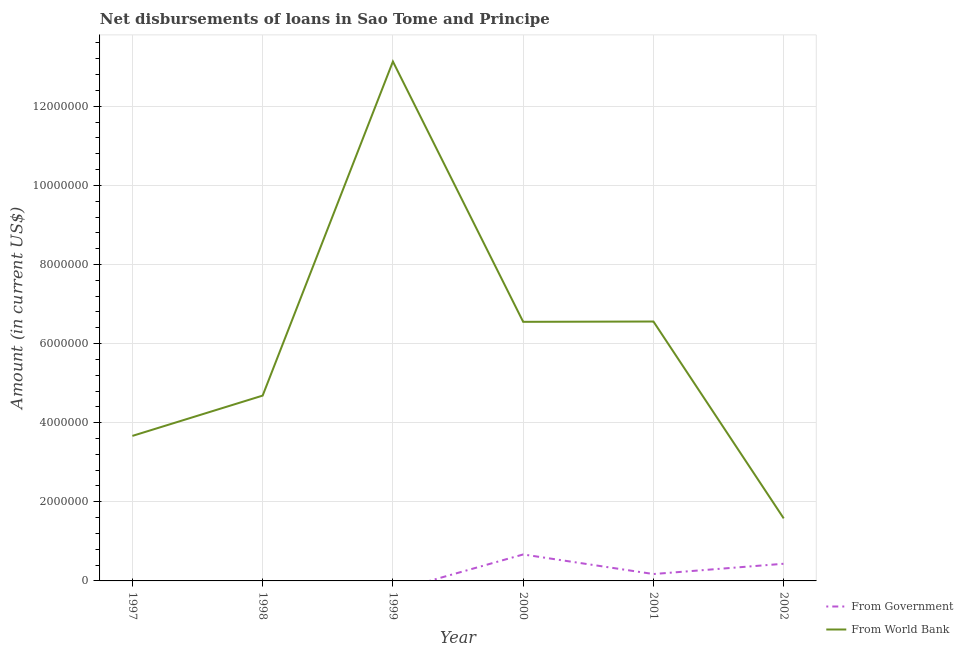Does the line corresponding to net disbursements of loan from world bank intersect with the line corresponding to net disbursements of loan from government?
Offer a terse response. No. Is the number of lines equal to the number of legend labels?
Provide a succinct answer. No. Across all years, what is the maximum net disbursements of loan from government?
Your answer should be very brief. 6.69e+05. Across all years, what is the minimum net disbursements of loan from government?
Provide a succinct answer. 0. What is the total net disbursements of loan from government in the graph?
Your response must be concise. 1.28e+06. What is the difference between the net disbursements of loan from world bank in 1998 and that in 1999?
Offer a terse response. -8.45e+06. What is the difference between the net disbursements of loan from government in 1998 and the net disbursements of loan from world bank in 1999?
Provide a short and direct response. -1.31e+07. What is the average net disbursements of loan from government per year?
Offer a very short reply. 2.13e+05. In the year 2001, what is the difference between the net disbursements of loan from government and net disbursements of loan from world bank?
Your answer should be compact. -6.38e+06. In how many years, is the net disbursements of loan from world bank greater than 11600000 US$?
Offer a very short reply. 1. What is the ratio of the net disbursements of loan from world bank in 2000 to that in 2001?
Your answer should be very brief. 1. Is the net disbursements of loan from government in 2001 less than that in 2002?
Offer a very short reply. Yes. What is the difference between the highest and the second highest net disbursements of loan from world bank?
Ensure brevity in your answer.  6.57e+06. What is the difference between the highest and the lowest net disbursements of loan from government?
Keep it short and to the point. 6.69e+05. Does the net disbursements of loan from government monotonically increase over the years?
Provide a succinct answer. No. Is the net disbursements of loan from government strictly greater than the net disbursements of loan from world bank over the years?
Your response must be concise. No. Is the net disbursements of loan from world bank strictly less than the net disbursements of loan from government over the years?
Your answer should be very brief. No. How many lines are there?
Give a very brief answer. 2. How many years are there in the graph?
Your response must be concise. 6. What is the difference between two consecutive major ticks on the Y-axis?
Offer a very short reply. 2.00e+06. Are the values on the major ticks of Y-axis written in scientific E-notation?
Give a very brief answer. No. Does the graph contain grids?
Your response must be concise. Yes. How many legend labels are there?
Your answer should be compact. 2. How are the legend labels stacked?
Offer a terse response. Vertical. What is the title of the graph?
Provide a short and direct response. Net disbursements of loans in Sao Tome and Principe. Does "External balance on goods" appear as one of the legend labels in the graph?
Offer a terse response. No. What is the label or title of the Y-axis?
Keep it short and to the point. Amount (in current US$). What is the Amount (in current US$) of From World Bank in 1997?
Give a very brief answer. 3.67e+06. What is the Amount (in current US$) of From World Bank in 1998?
Your answer should be very brief. 4.68e+06. What is the Amount (in current US$) in From World Bank in 1999?
Provide a succinct answer. 1.31e+07. What is the Amount (in current US$) in From Government in 2000?
Keep it short and to the point. 6.69e+05. What is the Amount (in current US$) in From World Bank in 2000?
Offer a very short reply. 6.55e+06. What is the Amount (in current US$) in From Government in 2001?
Offer a terse response. 1.74e+05. What is the Amount (in current US$) of From World Bank in 2001?
Give a very brief answer. 6.56e+06. What is the Amount (in current US$) of From Government in 2002?
Your response must be concise. 4.34e+05. What is the Amount (in current US$) in From World Bank in 2002?
Your answer should be very brief. 1.58e+06. Across all years, what is the maximum Amount (in current US$) of From Government?
Give a very brief answer. 6.69e+05. Across all years, what is the maximum Amount (in current US$) of From World Bank?
Your response must be concise. 1.31e+07. Across all years, what is the minimum Amount (in current US$) in From Government?
Give a very brief answer. 0. Across all years, what is the minimum Amount (in current US$) of From World Bank?
Provide a short and direct response. 1.58e+06. What is the total Amount (in current US$) of From Government in the graph?
Your answer should be very brief. 1.28e+06. What is the total Amount (in current US$) of From World Bank in the graph?
Provide a short and direct response. 3.62e+07. What is the difference between the Amount (in current US$) in From World Bank in 1997 and that in 1998?
Provide a short and direct response. -1.02e+06. What is the difference between the Amount (in current US$) of From World Bank in 1997 and that in 1999?
Give a very brief answer. -9.46e+06. What is the difference between the Amount (in current US$) in From World Bank in 1997 and that in 2000?
Make the answer very short. -2.88e+06. What is the difference between the Amount (in current US$) of From World Bank in 1997 and that in 2001?
Ensure brevity in your answer.  -2.89e+06. What is the difference between the Amount (in current US$) of From World Bank in 1997 and that in 2002?
Provide a succinct answer. 2.08e+06. What is the difference between the Amount (in current US$) of From World Bank in 1998 and that in 1999?
Provide a succinct answer. -8.45e+06. What is the difference between the Amount (in current US$) of From World Bank in 1998 and that in 2000?
Make the answer very short. -1.86e+06. What is the difference between the Amount (in current US$) of From World Bank in 1998 and that in 2001?
Provide a short and direct response. -1.87e+06. What is the difference between the Amount (in current US$) in From World Bank in 1998 and that in 2002?
Your response must be concise. 3.10e+06. What is the difference between the Amount (in current US$) in From World Bank in 1999 and that in 2000?
Your answer should be compact. 6.58e+06. What is the difference between the Amount (in current US$) of From World Bank in 1999 and that in 2001?
Your answer should be very brief. 6.57e+06. What is the difference between the Amount (in current US$) of From World Bank in 1999 and that in 2002?
Ensure brevity in your answer.  1.16e+07. What is the difference between the Amount (in current US$) in From Government in 2000 and that in 2001?
Ensure brevity in your answer.  4.95e+05. What is the difference between the Amount (in current US$) of From World Bank in 2000 and that in 2001?
Your answer should be very brief. -8000. What is the difference between the Amount (in current US$) in From Government in 2000 and that in 2002?
Your answer should be very brief. 2.35e+05. What is the difference between the Amount (in current US$) in From World Bank in 2000 and that in 2002?
Keep it short and to the point. 4.97e+06. What is the difference between the Amount (in current US$) of From World Bank in 2001 and that in 2002?
Your response must be concise. 4.98e+06. What is the difference between the Amount (in current US$) in From Government in 2000 and the Amount (in current US$) in From World Bank in 2001?
Offer a terse response. -5.89e+06. What is the difference between the Amount (in current US$) of From Government in 2000 and the Amount (in current US$) of From World Bank in 2002?
Provide a short and direct response. -9.12e+05. What is the difference between the Amount (in current US$) of From Government in 2001 and the Amount (in current US$) of From World Bank in 2002?
Your response must be concise. -1.41e+06. What is the average Amount (in current US$) of From Government per year?
Your answer should be very brief. 2.13e+05. What is the average Amount (in current US$) of From World Bank per year?
Offer a very short reply. 6.03e+06. In the year 2000, what is the difference between the Amount (in current US$) in From Government and Amount (in current US$) in From World Bank?
Provide a succinct answer. -5.88e+06. In the year 2001, what is the difference between the Amount (in current US$) of From Government and Amount (in current US$) of From World Bank?
Give a very brief answer. -6.38e+06. In the year 2002, what is the difference between the Amount (in current US$) in From Government and Amount (in current US$) in From World Bank?
Provide a succinct answer. -1.15e+06. What is the ratio of the Amount (in current US$) in From World Bank in 1997 to that in 1998?
Provide a short and direct response. 0.78. What is the ratio of the Amount (in current US$) of From World Bank in 1997 to that in 1999?
Ensure brevity in your answer.  0.28. What is the ratio of the Amount (in current US$) in From World Bank in 1997 to that in 2000?
Ensure brevity in your answer.  0.56. What is the ratio of the Amount (in current US$) in From World Bank in 1997 to that in 2001?
Offer a terse response. 0.56. What is the ratio of the Amount (in current US$) in From World Bank in 1997 to that in 2002?
Keep it short and to the point. 2.32. What is the ratio of the Amount (in current US$) in From World Bank in 1998 to that in 1999?
Keep it short and to the point. 0.36. What is the ratio of the Amount (in current US$) in From World Bank in 1998 to that in 2000?
Provide a short and direct response. 0.72. What is the ratio of the Amount (in current US$) of From World Bank in 1998 to that in 2001?
Provide a succinct answer. 0.71. What is the ratio of the Amount (in current US$) of From World Bank in 1998 to that in 2002?
Make the answer very short. 2.96. What is the ratio of the Amount (in current US$) of From World Bank in 1999 to that in 2000?
Offer a very short reply. 2. What is the ratio of the Amount (in current US$) of From World Bank in 1999 to that in 2001?
Make the answer very short. 2. What is the ratio of the Amount (in current US$) of From World Bank in 1999 to that in 2002?
Ensure brevity in your answer.  8.31. What is the ratio of the Amount (in current US$) of From Government in 2000 to that in 2001?
Offer a terse response. 3.84. What is the ratio of the Amount (in current US$) in From World Bank in 2000 to that in 2001?
Offer a very short reply. 1. What is the ratio of the Amount (in current US$) in From Government in 2000 to that in 2002?
Offer a very short reply. 1.54. What is the ratio of the Amount (in current US$) of From World Bank in 2000 to that in 2002?
Make the answer very short. 4.14. What is the ratio of the Amount (in current US$) of From Government in 2001 to that in 2002?
Your answer should be very brief. 0.4. What is the ratio of the Amount (in current US$) of From World Bank in 2001 to that in 2002?
Give a very brief answer. 4.15. What is the difference between the highest and the second highest Amount (in current US$) in From Government?
Ensure brevity in your answer.  2.35e+05. What is the difference between the highest and the second highest Amount (in current US$) in From World Bank?
Make the answer very short. 6.57e+06. What is the difference between the highest and the lowest Amount (in current US$) in From Government?
Your answer should be very brief. 6.69e+05. What is the difference between the highest and the lowest Amount (in current US$) in From World Bank?
Your answer should be very brief. 1.16e+07. 